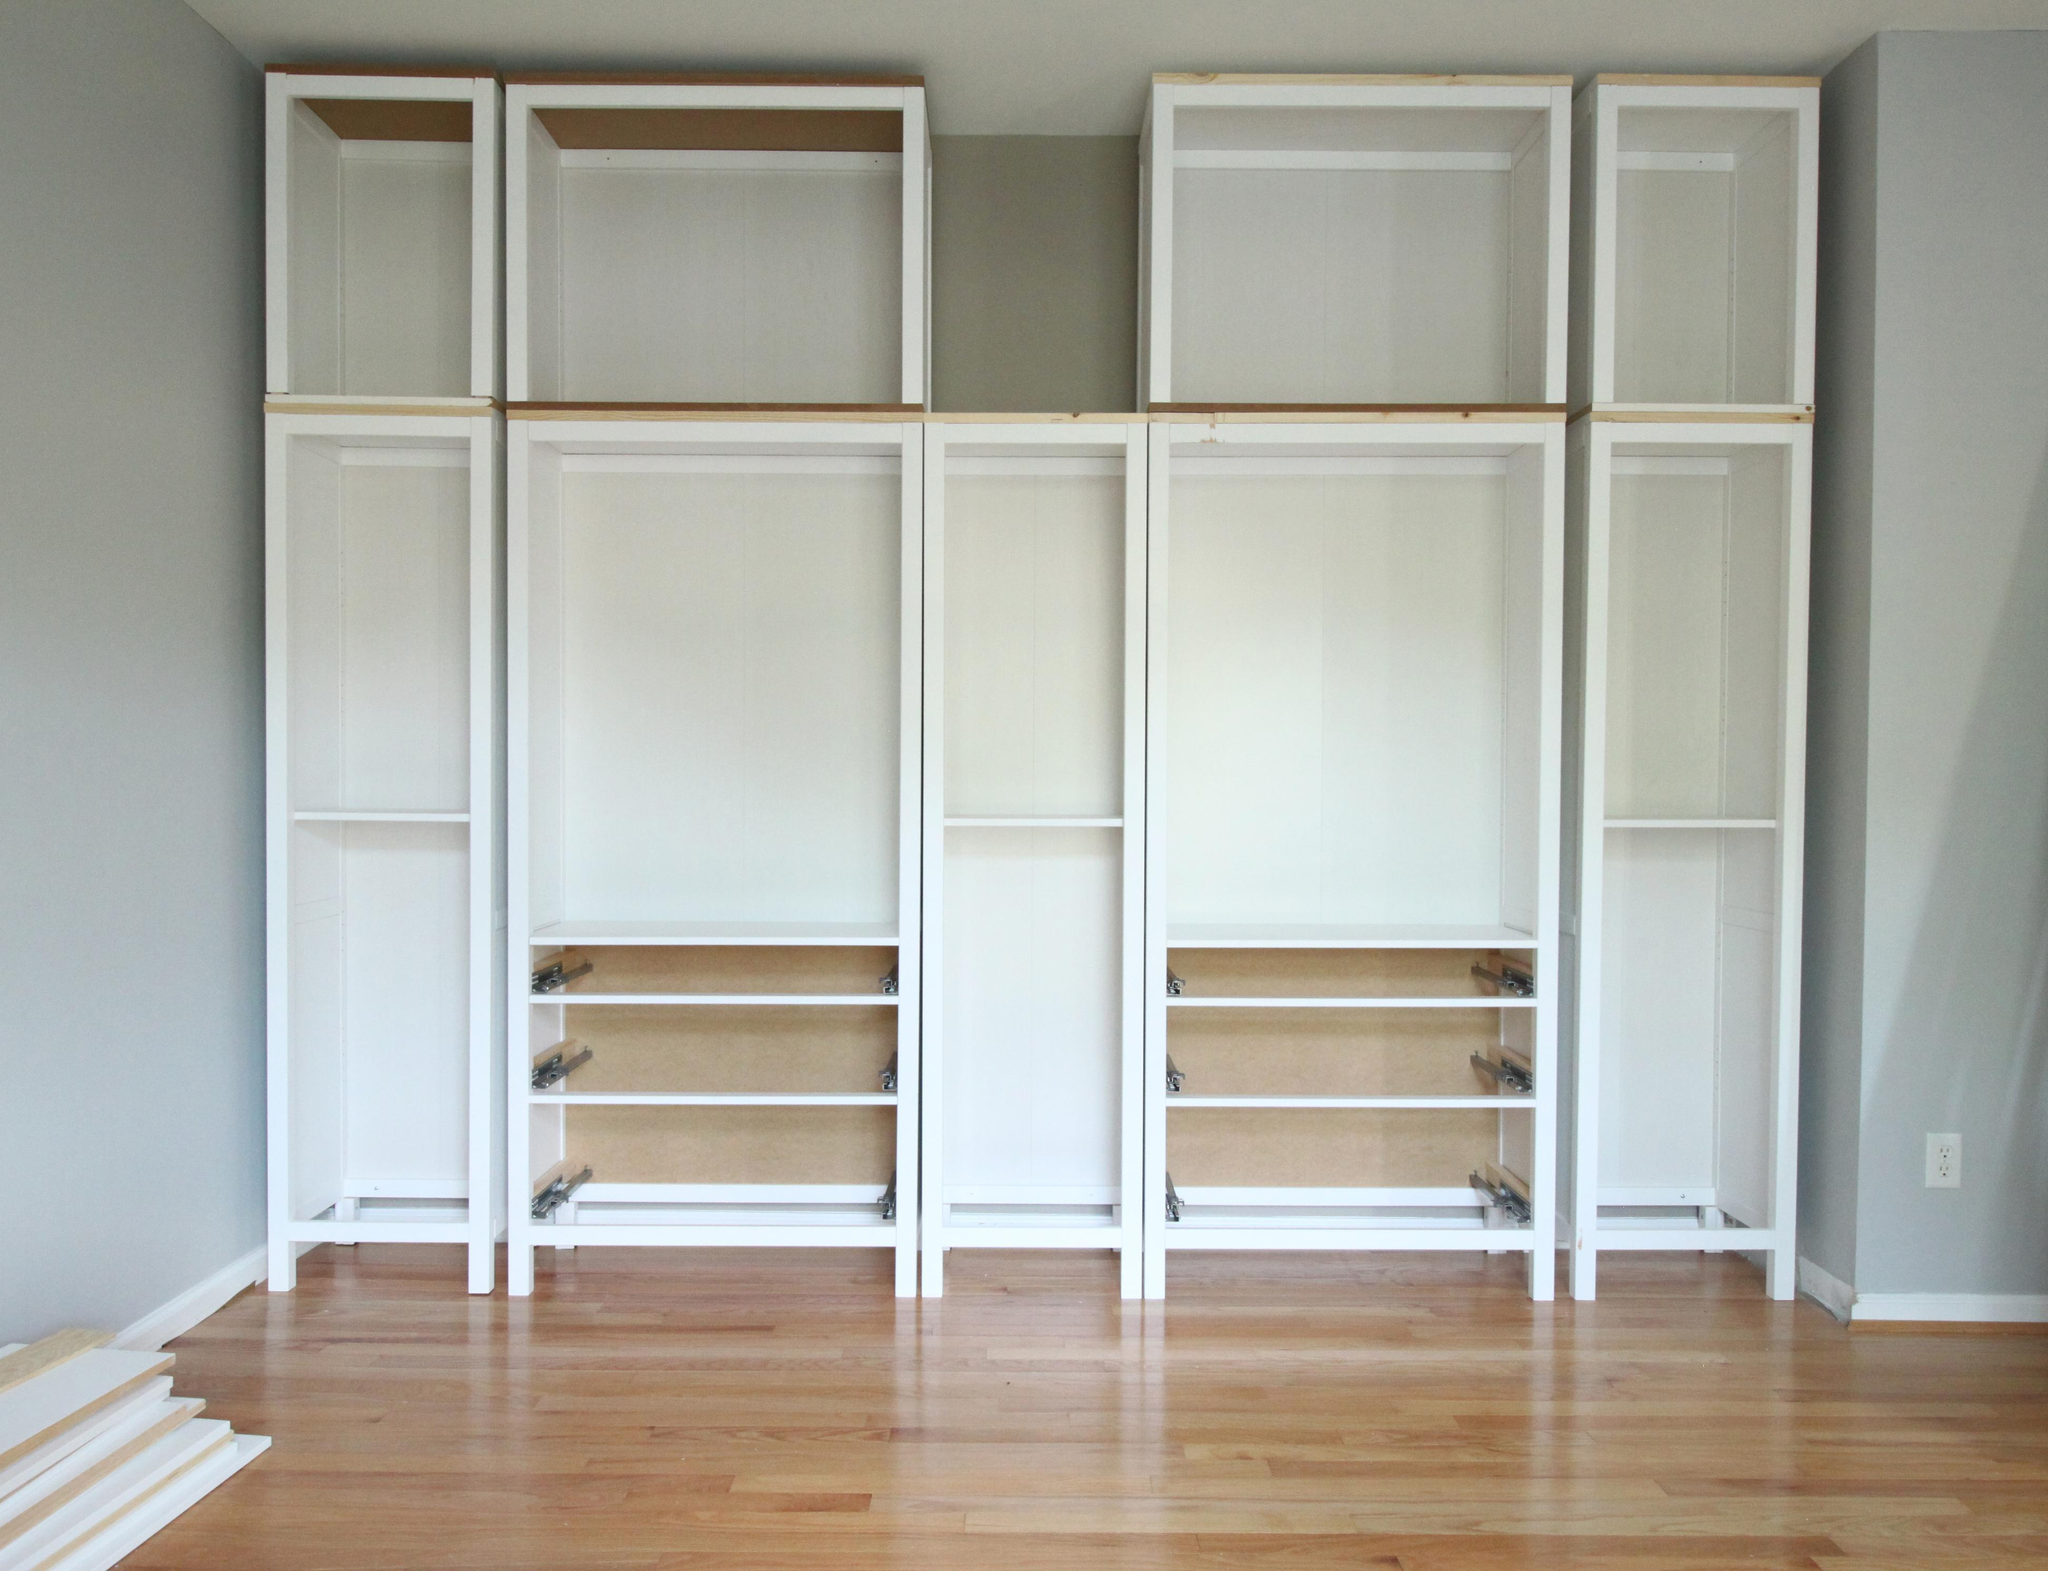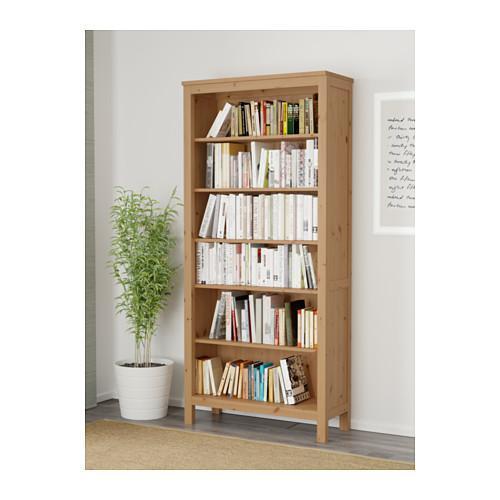The first image is the image on the left, the second image is the image on the right. For the images displayed, is the sentence "The left image contains a dark brown bookshelf." factually correct? Answer yes or no. No. 